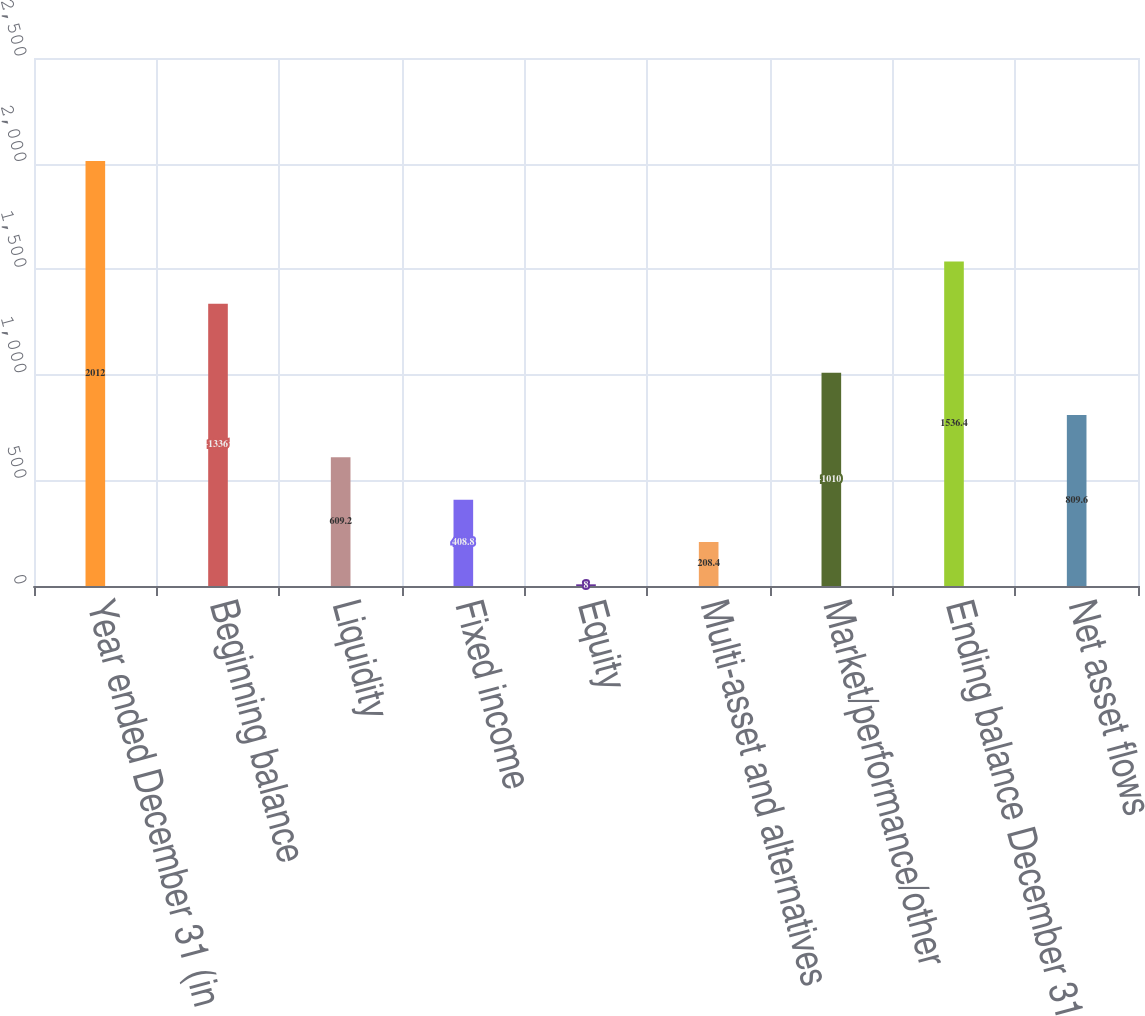Convert chart to OTSL. <chart><loc_0><loc_0><loc_500><loc_500><bar_chart><fcel>Year ended December 31 (in<fcel>Beginning balance<fcel>Liquidity<fcel>Fixed income<fcel>Equity<fcel>Multi-asset and alternatives<fcel>Market/performance/other<fcel>Ending balance December 31<fcel>Net asset flows<nl><fcel>2012<fcel>1336<fcel>609.2<fcel>408.8<fcel>8<fcel>208.4<fcel>1010<fcel>1536.4<fcel>809.6<nl></chart> 